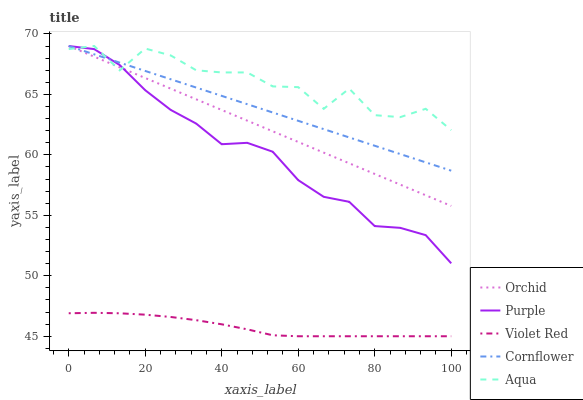Does Violet Red have the minimum area under the curve?
Answer yes or no. Yes. Does Aqua have the maximum area under the curve?
Answer yes or no. Yes. Does Cornflower have the minimum area under the curve?
Answer yes or no. No. Does Cornflower have the maximum area under the curve?
Answer yes or no. No. Is Orchid the smoothest?
Answer yes or no. Yes. Is Aqua the roughest?
Answer yes or no. Yes. Is Cornflower the smoothest?
Answer yes or no. No. Is Cornflower the roughest?
Answer yes or no. No. Does Violet Red have the lowest value?
Answer yes or no. Yes. Does Cornflower have the lowest value?
Answer yes or no. No. Does Orchid have the highest value?
Answer yes or no. Yes. Does Violet Red have the highest value?
Answer yes or no. No. Is Violet Red less than Purple?
Answer yes or no. Yes. Is Orchid greater than Violet Red?
Answer yes or no. Yes. Does Purple intersect Aqua?
Answer yes or no. Yes. Is Purple less than Aqua?
Answer yes or no. No. Is Purple greater than Aqua?
Answer yes or no. No. Does Violet Red intersect Purple?
Answer yes or no. No. 